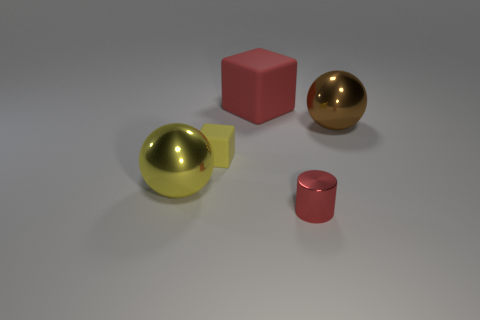Can you describe the red block to the left? The red block to the left appears to be a standard cube, with a surface that exhibits a slight matte texture. Its scale is smaller in comparison to the golden sphere beside it. 